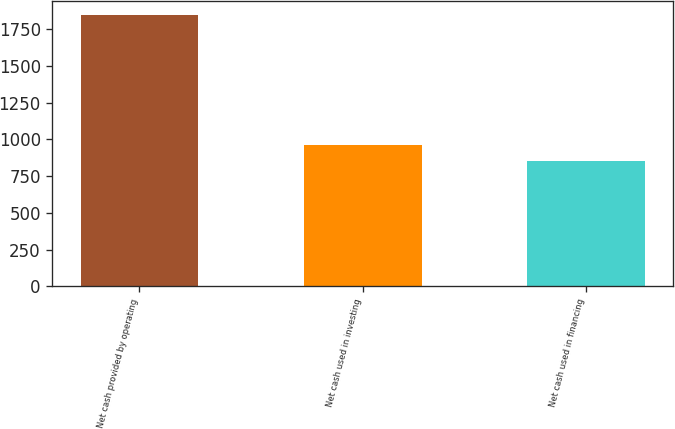Convert chart. <chart><loc_0><loc_0><loc_500><loc_500><bar_chart><fcel>Net cash provided by operating<fcel>Net cash used in investing<fcel>Net cash used in financing<nl><fcel>1847.8<fcel>961.2<fcel>851.2<nl></chart> 